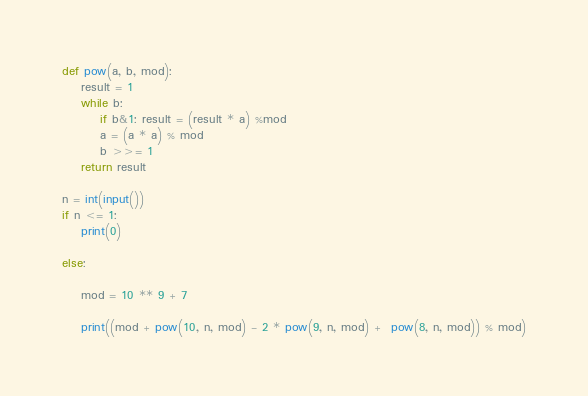Convert code to text. <code><loc_0><loc_0><loc_500><loc_500><_Python_>def pow(a, b, mod):
    result = 1
    while b:
        if b&1: result = (result * a) %mod
        a = (a * a) % mod
        b >>= 1
    return result

n = int(input())
if n <= 1:
    print(0)

else:

    mod = 10 ** 9 + 7

    print((mod + pow(10, n, mod) - 2 * pow(9, n, mod) +  pow(8, n, mod)) % mod)</code> 